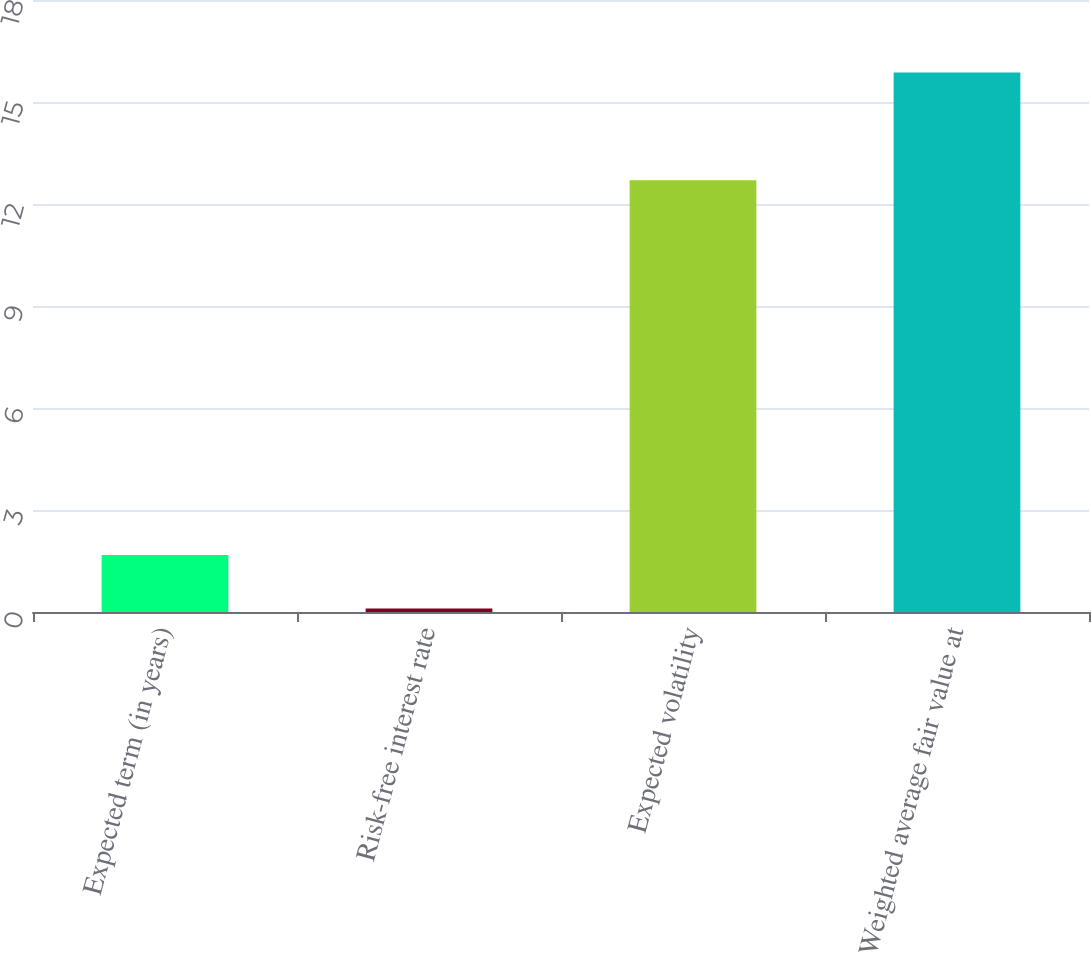Convert chart. <chart><loc_0><loc_0><loc_500><loc_500><bar_chart><fcel>Expected term (in years)<fcel>Risk-free interest rate<fcel>Expected volatility<fcel>Weighted average fair value at<nl><fcel>1.68<fcel>0.1<fcel>12.7<fcel>15.87<nl></chart> 